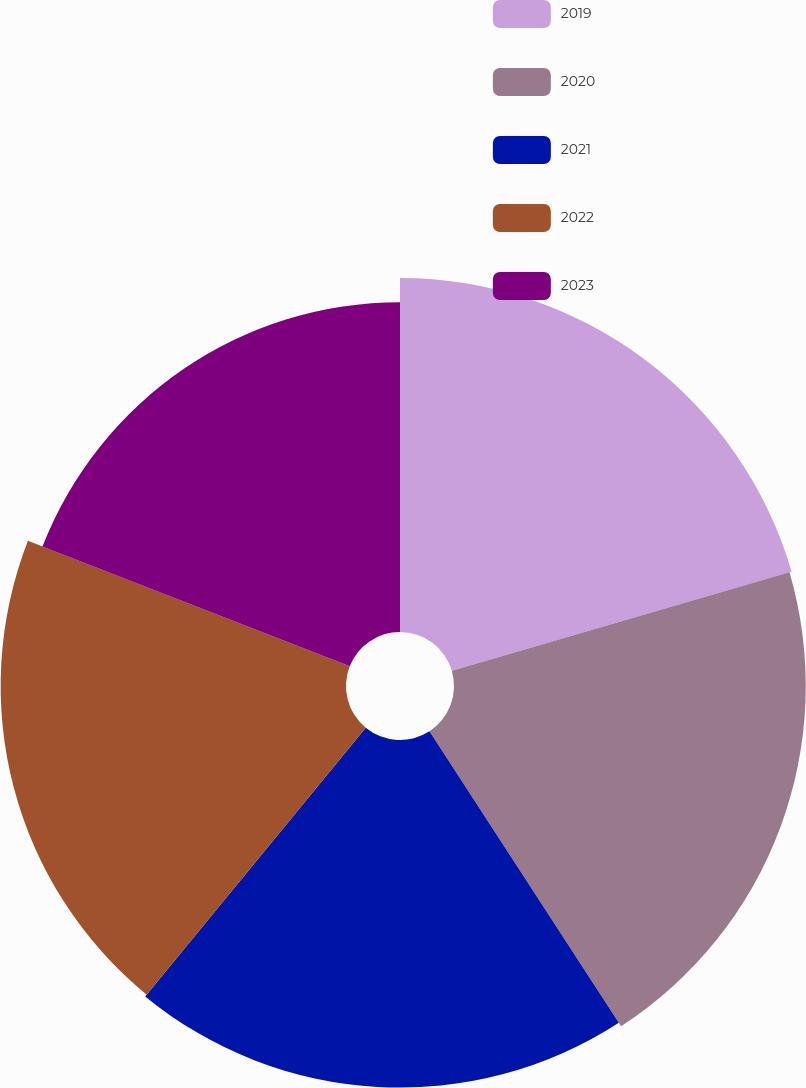<chart> <loc_0><loc_0><loc_500><loc_500><pie_chart><fcel>2019<fcel>2020<fcel>2021<fcel>2022<fcel>2023<nl><fcel>20.48%<fcel>20.35%<fcel>20.11%<fcel>19.98%<fcel>19.08%<nl></chart> 